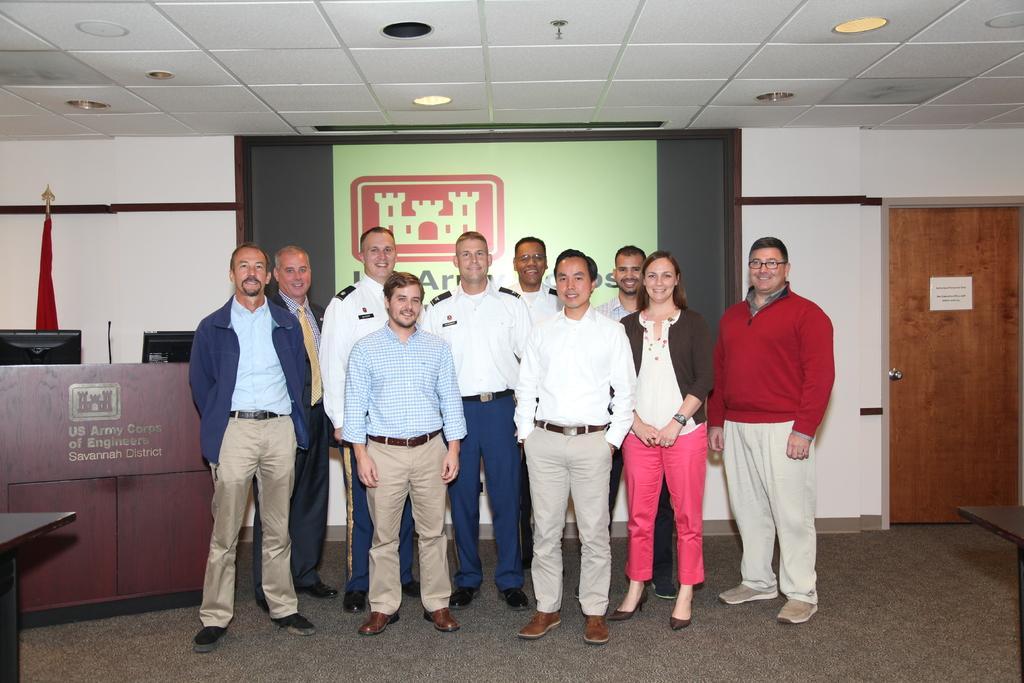In one or two sentences, can you explain what this image depicts? In the image we can see there are men and a woman standing, they are wearing clothes, shoes and they are smiling. Here we can see the door, made up of wood, carpet, poster, systems, microphone and lights. 